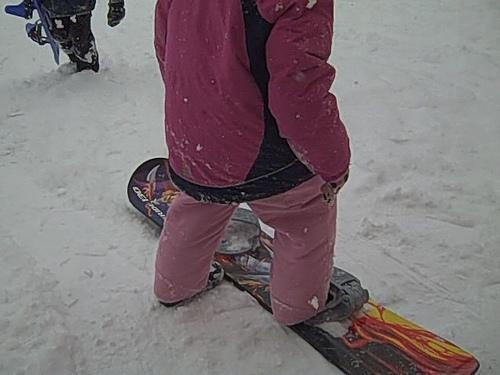How would it be if she tried to snowboard assis?
From the following set of four choices, select the accurate answer to respond to the question.
Options: Too cold, too hot, no problem, too dangerous. Too dangerous. 